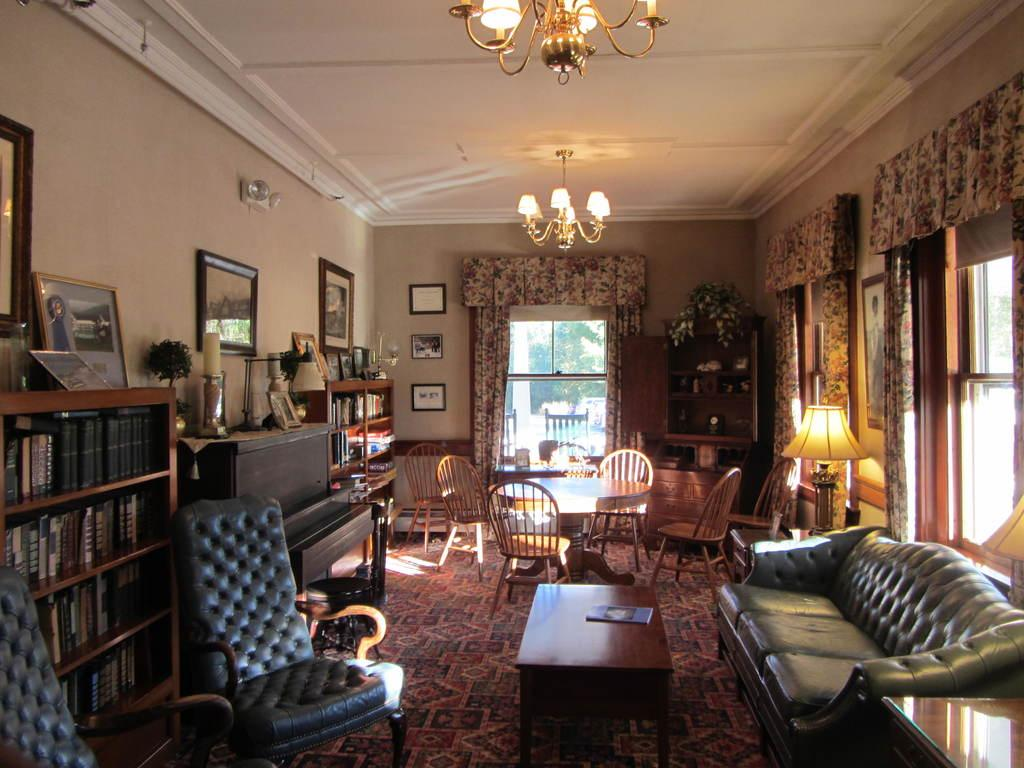What type of furniture is present in the image? There is a couch, a chair, and a table in the image. What is placed on the table in the image? There is a book on the table in the image. What type of storage is visible in the image? There are book racks in the image. What type of decorative items can be seen in the image? There are frames in the image. What type of plant container is present in the image? There is a flower pot in the image. What type of company is conducting a meeting in the image? There is no indication of a company or meeting in the image; it features furniture, a book, book racks, frames, and a flower pot. What type of pen is visible in the image? There is no pen present in the image. 